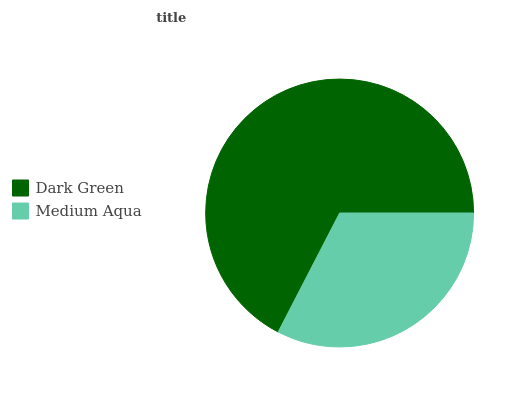Is Medium Aqua the minimum?
Answer yes or no. Yes. Is Dark Green the maximum?
Answer yes or no. Yes. Is Medium Aqua the maximum?
Answer yes or no. No. Is Dark Green greater than Medium Aqua?
Answer yes or no. Yes. Is Medium Aqua less than Dark Green?
Answer yes or no. Yes. Is Medium Aqua greater than Dark Green?
Answer yes or no. No. Is Dark Green less than Medium Aqua?
Answer yes or no. No. Is Dark Green the high median?
Answer yes or no. Yes. Is Medium Aqua the low median?
Answer yes or no. Yes. Is Medium Aqua the high median?
Answer yes or no. No. Is Dark Green the low median?
Answer yes or no. No. 